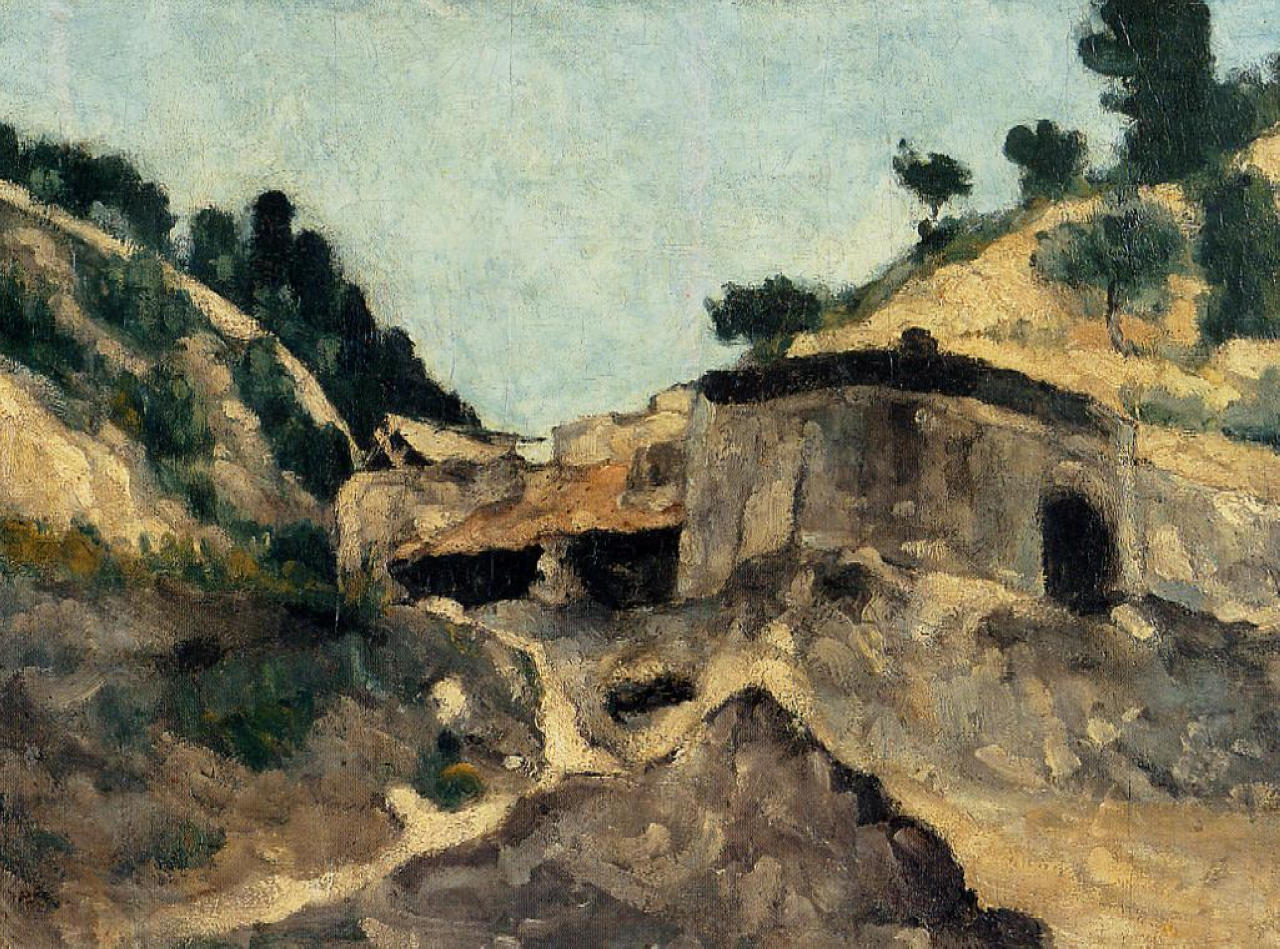Can you describe the mood that this artwork conveys? The artwork exudes a mood of serene wistfulness. The dilapidated stone building, standing resilient amidst the rolling hills and trees, evokes a sense of enduring history and gentle melancholy. The impressionistic brushstrokes breathe life and movement into the scene, adding to the calm ambiance. The soft, blue tones of the sky offer tranquility and contemplation, inviting viewers to wander through time and nature. What kind of stories might have unfolded in the old stone building? The old stone building might have been a bustling homestead, sheltering generations of families. Imagine the laughter and chatter filling the rooms, the aroma of meals being prepared in the hearth, and children playing around its sturdy walls. Over time, the building could have witnessed quiet moments of reflection, as the inhabitants gazed over the undulating landscape. As years wore on, it might have become a solitary abode, standing testament to the whispers of the past and the relentless march of nature reclaiming its space. 